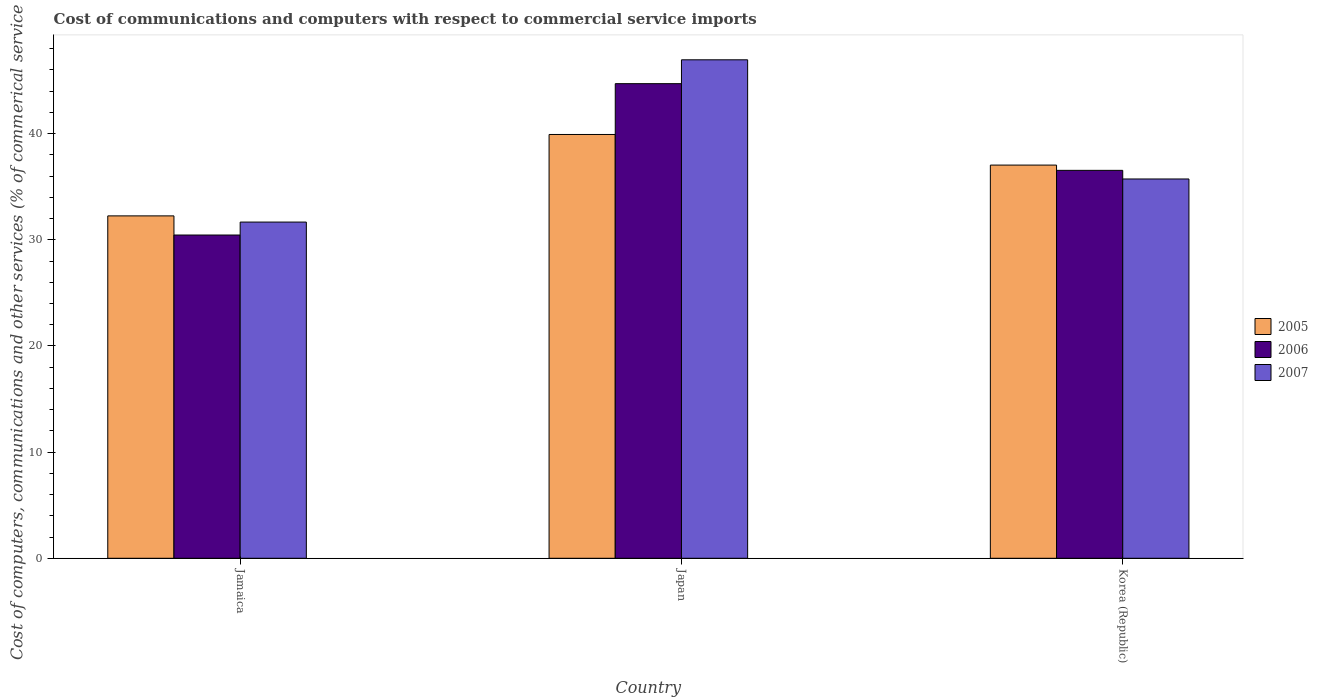How many different coloured bars are there?
Give a very brief answer. 3. Are the number of bars per tick equal to the number of legend labels?
Give a very brief answer. Yes. Are the number of bars on each tick of the X-axis equal?
Offer a very short reply. Yes. How many bars are there on the 3rd tick from the left?
Make the answer very short. 3. What is the label of the 2nd group of bars from the left?
Ensure brevity in your answer.  Japan. In how many cases, is the number of bars for a given country not equal to the number of legend labels?
Your answer should be very brief. 0. What is the cost of communications and computers in 2007 in Jamaica?
Your answer should be compact. 31.67. Across all countries, what is the maximum cost of communications and computers in 2007?
Offer a very short reply. 46.96. Across all countries, what is the minimum cost of communications and computers in 2005?
Your response must be concise. 32.25. In which country was the cost of communications and computers in 2005 maximum?
Give a very brief answer. Japan. In which country was the cost of communications and computers in 2006 minimum?
Provide a short and direct response. Jamaica. What is the total cost of communications and computers in 2007 in the graph?
Keep it short and to the point. 114.36. What is the difference between the cost of communications and computers in 2006 in Jamaica and that in Korea (Republic)?
Give a very brief answer. -6.09. What is the difference between the cost of communications and computers in 2005 in Jamaica and the cost of communications and computers in 2007 in Japan?
Offer a very short reply. -14.7. What is the average cost of communications and computers in 2006 per country?
Your answer should be very brief. 37.23. What is the difference between the cost of communications and computers of/in 2006 and cost of communications and computers of/in 2005 in Jamaica?
Your answer should be compact. -1.8. In how many countries, is the cost of communications and computers in 2005 greater than 20 %?
Ensure brevity in your answer.  3. What is the ratio of the cost of communications and computers in 2005 in Jamaica to that in Japan?
Make the answer very short. 0.81. What is the difference between the highest and the second highest cost of communications and computers in 2007?
Offer a terse response. -11.23. What is the difference between the highest and the lowest cost of communications and computers in 2007?
Your answer should be compact. 15.29. What does the 2nd bar from the right in Jamaica represents?
Your answer should be compact. 2006. Is it the case that in every country, the sum of the cost of communications and computers in 2007 and cost of communications and computers in 2005 is greater than the cost of communications and computers in 2006?
Provide a succinct answer. Yes. How many bars are there?
Your answer should be very brief. 9. Are all the bars in the graph horizontal?
Keep it short and to the point. No. What is the difference between two consecutive major ticks on the Y-axis?
Offer a very short reply. 10. Does the graph contain any zero values?
Make the answer very short. No. What is the title of the graph?
Give a very brief answer. Cost of communications and computers with respect to commercial service imports. Does "2002" appear as one of the legend labels in the graph?
Your response must be concise. No. What is the label or title of the Y-axis?
Your answer should be very brief. Cost of computers, communications and other services (% of commerical service exports). What is the Cost of computers, communications and other services (% of commerical service exports) in 2005 in Jamaica?
Your answer should be compact. 32.25. What is the Cost of computers, communications and other services (% of commerical service exports) of 2006 in Jamaica?
Provide a short and direct response. 30.45. What is the Cost of computers, communications and other services (% of commerical service exports) of 2007 in Jamaica?
Offer a very short reply. 31.67. What is the Cost of computers, communications and other services (% of commerical service exports) of 2005 in Japan?
Offer a terse response. 39.92. What is the Cost of computers, communications and other services (% of commerical service exports) in 2006 in Japan?
Keep it short and to the point. 44.71. What is the Cost of computers, communications and other services (% of commerical service exports) in 2007 in Japan?
Your answer should be very brief. 46.96. What is the Cost of computers, communications and other services (% of commerical service exports) in 2005 in Korea (Republic)?
Your answer should be very brief. 37.04. What is the Cost of computers, communications and other services (% of commerical service exports) of 2006 in Korea (Republic)?
Your response must be concise. 36.54. What is the Cost of computers, communications and other services (% of commerical service exports) of 2007 in Korea (Republic)?
Offer a very short reply. 35.73. Across all countries, what is the maximum Cost of computers, communications and other services (% of commerical service exports) in 2005?
Your answer should be compact. 39.92. Across all countries, what is the maximum Cost of computers, communications and other services (% of commerical service exports) in 2006?
Ensure brevity in your answer.  44.71. Across all countries, what is the maximum Cost of computers, communications and other services (% of commerical service exports) of 2007?
Offer a terse response. 46.96. Across all countries, what is the minimum Cost of computers, communications and other services (% of commerical service exports) of 2005?
Your response must be concise. 32.25. Across all countries, what is the minimum Cost of computers, communications and other services (% of commerical service exports) of 2006?
Provide a succinct answer. 30.45. Across all countries, what is the minimum Cost of computers, communications and other services (% of commerical service exports) of 2007?
Offer a terse response. 31.67. What is the total Cost of computers, communications and other services (% of commerical service exports) of 2005 in the graph?
Provide a succinct answer. 109.21. What is the total Cost of computers, communications and other services (% of commerical service exports) of 2006 in the graph?
Keep it short and to the point. 111.7. What is the total Cost of computers, communications and other services (% of commerical service exports) in 2007 in the graph?
Provide a succinct answer. 114.36. What is the difference between the Cost of computers, communications and other services (% of commerical service exports) of 2005 in Jamaica and that in Japan?
Ensure brevity in your answer.  -7.67. What is the difference between the Cost of computers, communications and other services (% of commerical service exports) of 2006 in Jamaica and that in Japan?
Ensure brevity in your answer.  -14.26. What is the difference between the Cost of computers, communications and other services (% of commerical service exports) of 2007 in Jamaica and that in Japan?
Your answer should be compact. -15.29. What is the difference between the Cost of computers, communications and other services (% of commerical service exports) of 2005 in Jamaica and that in Korea (Republic)?
Offer a very short reply. -4.79. What is the difference between the Cost of computers, communications and other services (% of commerical service exports) of 2006 in Jamaica and that in Korea (Republic)?
Ensure brevity in your answer.  -6.09. What is the difference between the Cost of computers, communications and other services (% of commerical service exports) in 2007 in Jamaica and that in Korea (Republic)?
Your answer should be compact. -4.06. What is the difference between the Cost of computers, communications and other services (% of commerical service exports) in 2005 in Japan and that in Korea (Republic)?
Provide a succinct answer. 2.88. What is the difference between the Cost of computers, communications and other services (% of commerical service exports) of 2006 in Japan and that in Korea (Republic)?
Offer a very short reply. 8.17. What is the difference between the Cost of computers, communications and other services (% of commerical service exports) in 2007 in Japan and that in Korea (Republic)?
Offer a terse response. 11.23. What is the difference between the Cost of computers, communications and other services (% of commerical service exports) in 2005 in Jamaica and the Cost of computers, communications and other services (% of commerical service exports) in 2006 in Japan?
Ensure brevity in your answer.  -12.45. What is the difference between the Cost of computers, communications and other services (% of commerical service exports) of 2005 in Jamaica and the Cost of computers, communications and other services (% of commerical service exports) of 2007 in Japan?
Offer a terse response. -14.7. What is the difference between the Cost of computers, communications and other services (% of commerical service exports) in 2006 in Jamaica and the Cost of computers, communications and other services (% of commerical service exports) in 2007 in Japan?
Offer a very short reply. -16.51. What is the difference between the Cost of computers, communications and other services (% of commerical service exports) in 2005 in Jamaica and the Cost of computers, communications and other services (% of commerical service exports) in 2006 in Korea (Republic)?
Your answer should be very brief. -4.29. What is the difference between the Cost of computers, communications and other services (% of commerical service exports) of 2005 in Jamaica and the Cost of computers, communications and other services (% of commerical service exports) of 2007 in Korea (Republic)?
Your answer should be compact. -3.48. What is the difference between the Cost of computers, communications and other services (% of commerical service exports) in 2006 in Jamaica and the Cost of computers, communications and other services (% of commerical service exports) in 2007 in Korea (Republic)?
Give a very brief answer. -5.28. What is the difference between the Cost of computers, communications and other services (% of commerical service exports) in 2005 in Japan and the Cost of computers, communications and other services (% of commerical service exports) in 2006 in Korea (Republic)?
Give a very brief answer. 3.38. What is the difference between the Cost of computers, communications and other services (% of commerical service exports) in 2005 in Japan and the Cost of computers, communications and other services (% of commerical service exports) in 2007 in Korea (Republic)?
Provide a succinct answer. 4.19. What is the difference between the Cost of computers, communications and other services (% of commerical service exports) in 2006 in Japan and the Cost of computers, communications and other services (% of commerical service exports) in 2007 in Korea (Republic)?
Provide a succinct answer. 8.98. What is the average Cost of computers, communications and other services (% of commerical service exports) of 2005 per country?
Offer a terse response. 36.4. What is the average Cost of computers, communications and other services (% of commerical service exports) of 2006 per country?
Provide a short and direct response. 37.23. What is the average Cost of computers, communications and other services (% of commerical service exports) of 2007 per country?
Your response must be concise. 38.12. What is the difference between the Cost of computers, communications and other services (% of commerical service exports) of 2005 and Cost of computers, communications and other services (% of commerical service exports) of 2006 in Jamaica?
Your answer should be very brief. 1.8. What is the difference between the Cost of computers, communications and other services (% of commerical service exports) in 2005 and Cost of computers, communications and other services (% of commerical service exports) in 2007 in Jamaica?
Provide a short and direct response. 0.58. What is the difference between the Cost of computers, communications and other services (% of commerical service exports) of 2006 and Cost of computers, communications and other services (% of commerical service exports) of 2007 in Jamaica?
Offer a terse response. -1.22. What is the difference between the Cost of computers, communications and other services (% of commerical service exports) in 2005 and Cost of computers, communications and other services (% of commerical service exports) in 2006 in Japan?
Your response must be concise. -4.79. What is the difference between the Cost of computers, communications and other services (% of commerical service exports) of 2005 and Cost of computers, communications and other services (% of commerical service exports) of 2007 in Japan?
Offer a terse response. -7.03. What is the difference between the Cost of computers, communications and other services (% of commerical service exports) in 2006 and Cost of computers, communications and other services (% of commerical service exports) in 2007 in Japan?
Give a very brief answer. -2.25. What is the difference between the Cost of computers, communications and other services (% of commerical service exports) of 2005 and Cost of computers, communications and other services (% of commerical service exports) of 2006 in Korea (Republic)?
Your answer should be very brief. 0.5. What is the difference between the Cost of computers, communications and other services (% of commerical service exports) of 2005 and Cost of computers, communications and other services (% of commerical service exports) of 2007 in Korea (Republic)?
Provide a short and direct response. 1.31. What is the difference between the Cost of computers, communications and other services (% of commerical service exports) of 2006 and Cost of computers, communications and other services (% of commerical service exports) of 2007 in Korea (Republic)?
Offer a terse response. 0.81. What is the ratio of the Cost of computers, communications and other services (% of commerical service exports) in 2005 in Jamaica to that in Japan?
Give a very brief answer. 0.81. What is the ratio of the Cost of computers, communications and other services (% of commerical service exports) of 2006 in Jamaica to that in Japan?
Ensure brevity in your answer.  0.68. What is the ratio of the Cost of computers, communications and other services (% of commerical service exports) of 2007 in Jamaica to that in Japan?
Keep it short and to the point. 0.67. What is the ratio of the Cost of computers, communications and other services (% of commerical service exports) in 2005 in Jamaica to that in Korea (Republic)?
Your answer should be very brief. 0.87. What is the ratio of the Cost of computers, communications and other services (% of commerical service exports) in 2006 in Jamaica to that in Korea (Republic)?
Your response must be concise. 0.83. What is the ratio of the Cost of computers, communications and other services (% of commerical service exports) in 2007 in Jamaica to that in Korea (Republic)?
Give a very brief answer. 0.89. What is the ratio of the Cost of computers, communications and other services (% of commerical service exports) of 2005 in Japan to that in Korea (Republic)?
Your answer should be very brief. 1.08. What is the ratio of the Cost of computers, communications and other services (% of commerical service exports) in 2006 in Japan to that in Korea (Republic)?
Make the answer very short. 1.22. What is the ratio of the Cost of computers, communications and other services (% of commerical service exports) in 2007 in Japan to that in Korea (Republic)?
Give a very brief answer. 1.31. What is the difference between the highest and the second highest Cost of computers, communications and other services (% of commerical service exports) in 2005?
Your response must be concise. 2.88. What is the difference between the highest and the second highest Cost of computers, communications and other services (% of commerical service exports) in 2006?
Your answer should be compact. 8.17. What is the difference between the highest and the second highest Cost of computers, communications and other services (% of commerical service exports) in 2007?
Ensure brevity in your answer.  11.23. What is the difference between the highest and the lowest Cost of computers, communications and other services (% of commerical service exports) in 2005?
Make the answer very short. 7.67. What is the difference between the highest and the lowest Cost of computers, communications and other services (% of commerical service exports) in 2006?
Your answer should be very brief. 14.26. What is the difference between the highest and the lowest Cost of computers, communications and other services (% of commerical service exports) of 2007?
Offer a very short reply. 15.29. 